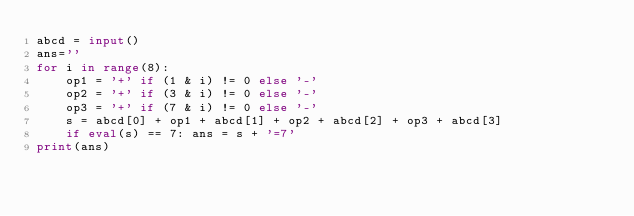<code> <loc_0><loc_0><loc_500><loc_500><_Python_>abcd = input()
ans=''
for i in range(8):
    op1 = '+' if (1 & i) != 0 else '-'
    op2 = '+' if (3 & i) != 0 else '-'
    op3 = '+' if (7 & i) != 0 else '-'
    s = abcd[0] + op1 + abcd[1] + op2 + abcd[2] + op3 + abcd[3]
    if eval(s) == 7: ans = s + '=7'
print(ans)
</code> 